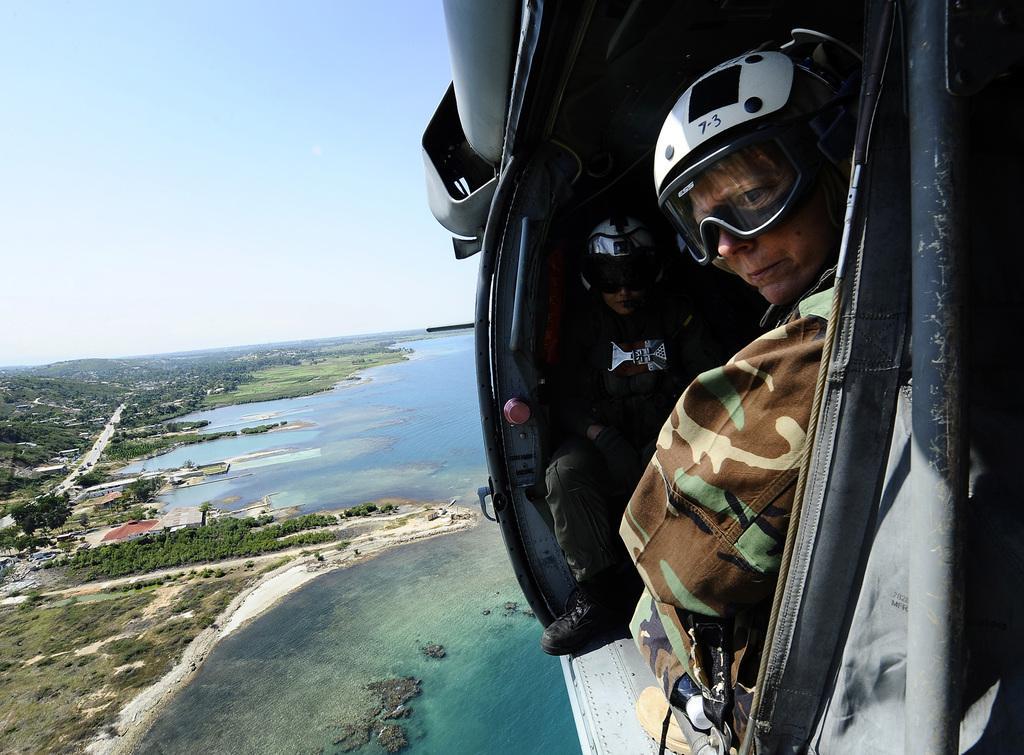In one or two sentences, can you explain what this image depicts? In this picture I can see it looks like two persons are sitting in the helicopter, at the bottom there is water. On the left side there are trees, at the top there is the sky. 